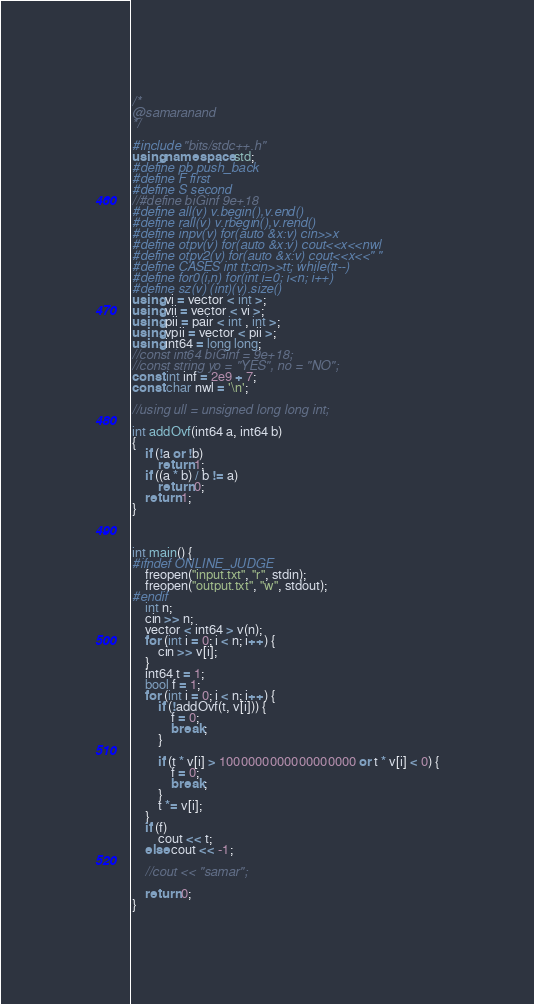<code> <loc_0><loc_0><loc_500><loc_500><_C++_>/*
@samaranand
*/

#include "bits/stdc++.h"
using namespace std;
#define pb push_back
#define F first
#define S second
//#define biGinf 9e+18
#define all(v) v.begin(),v.end()
#define rall(v) v.rbegin(),v.rend()
#define inpv(v) for(auto &x:v) cin>>x
#define otpv(v) for(auto &x:v) cout<<x<<nwl
#define otpv2(v) for(auto &x:v) cout<<x<<" "
#define CASES int tt;cin>>tt; while(tt--)
#define for0(i,n) for(int i=0; i<n; i++)
#define sz(v) (int)(v).size()
using vi = vector < int >;
using vii = vector < vi >;
using pii = pair < int , int >;
using vpii = vector < pii >;
using int64 = long long;
//const int64 biGinf = 9e+18;
//const string yo = "YES", no = "NO";
const int inf = 2e9 + 7;
const char nwl = '\n';

//using ull = unsigned long long int;

int addOvf(int64 a, int64 b)
{
	if (!a or !b)
		return 1;
	if ((a * b) / b != a)
		return 0;
	return 1;
}



int main() {
#ifndef ONLINE_JUDGE
	freopen("input.txt", "r", stdin);
	freopen("output.txt", "w", stdout);
#endif
	int n;
	cin >> n;
	vector < int64 > v(n);
	for (int i = 0; i < n; i++) {
		cin >> v[i];
	}
	int64 t = 1;
	bool f = 1;
	for (int i = 0; i < n; i++) {
		if (!addOvf(t, v[i])) {
			f = 0;
			break;
		}

		if (t * v[i] > 1000000000000000000 or t * v[i] < 0) {
			f = 0;
			break;
		}
		t *= v[i];
	}
	if (f)
		cout << t;
	else cout << -1;

	//cout << "samar";

	return 0;
}
</code> 